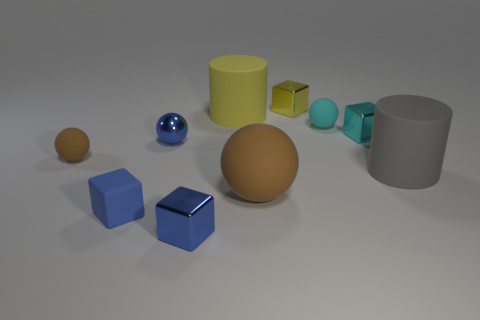Subtract all spheres. How many objects are left? 6 Subtract all tiny cyan rubber spheres. Subtract all big brown rubber cylinders. How many objects are left? 9 Add 4 brown matte balls. How many brown matte balls are left? 6 Add 8 big green cylinders. How many big green cylinders exist? 8 Subtract 0 purple cylinders. How many objects are left? 10 